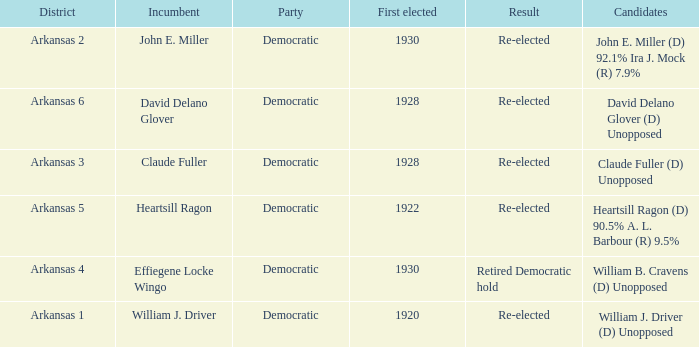Who ran in the election where Claude Fuller was the incumbent?  Claude Fuller (D) Unopposed. 